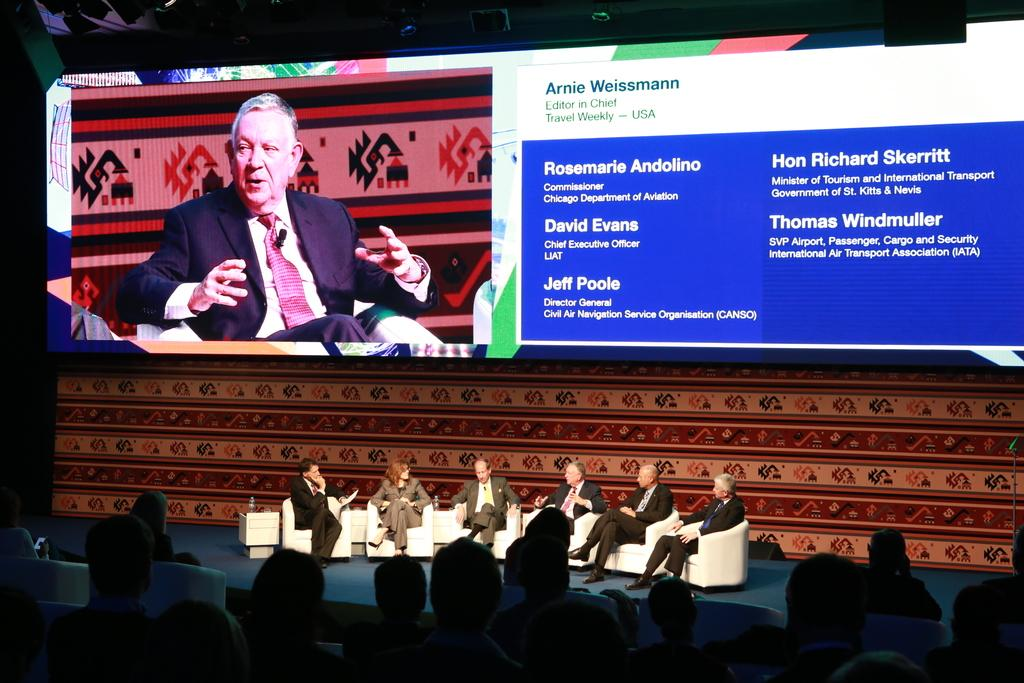What is located at the top of the image? There is a screen visible at the top of the image. What can be seen on the screen? There is a person's image on the screen. What additional information is provided with the person's image? There is text associated with the person's image. What is the position of the persons in the image? There are persons sitting on chairs at the bottom of the image. What type of scarecrow can be seen in the image? There is no scarecrow present in the image. What action is the person taking in the image? The image does not depict any specific action being taken by the person; it only shows their image on the screen. 